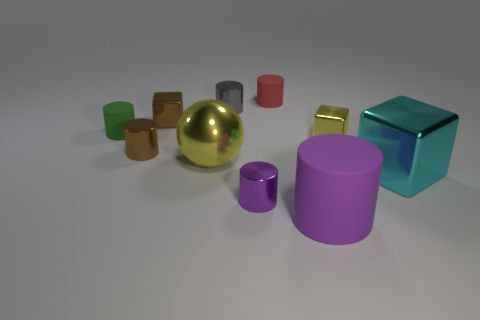Subtract all red cylinders. How many cylinders are left? 5 Subtract all green cylinders. How many cylinders are left? 5 Subtract 2 cylinders. How many cylinders are left? 4 Subtract all blue cubes. Subtract all blue balls. How many cubes are left? 3 Subtract all cubes. How many objects are left? 7 Add 8 big purple matte cylinders. How many big purple matte cylinders exist? 9 Subtract 1 cyan cubes. How many objects are left? 9 Subtract all tiny cubes. Subtract all small metallic blocks. How many objects are left? 6 Add 8 small red rubber cylinders. How many small red rubber cylinders are left? 9 